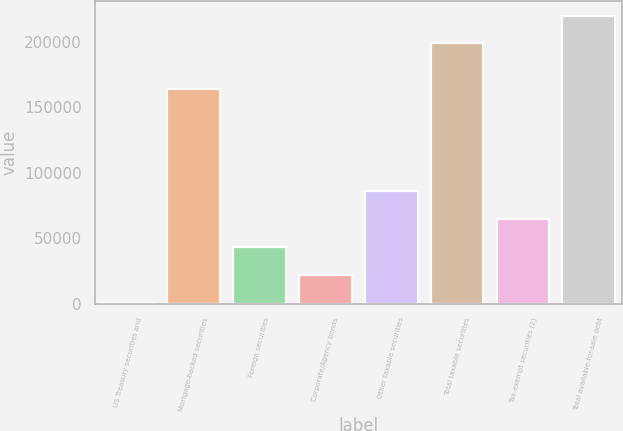Convert chart to OTSL. <chart><loc_0><loc_0><loc_500><loc_500><bar_chart><fcel>US Treasury securities and<fcel>Mortgage-backed securities<fcel>Foreign securities<fcel>Corporate/Agency bonds<fcel>Other taxable securities<fcel>Total taxable securities<fcel>Tax-exempt securities (2)<fcel>Total available-for-sale debt<nl><fcel>759<fcel>163716<fcel>43273.2<fcel>22016.1<fcel>85787.4<fcel>198858<fcel>64530.3<fcel>220115<nl></chart> 